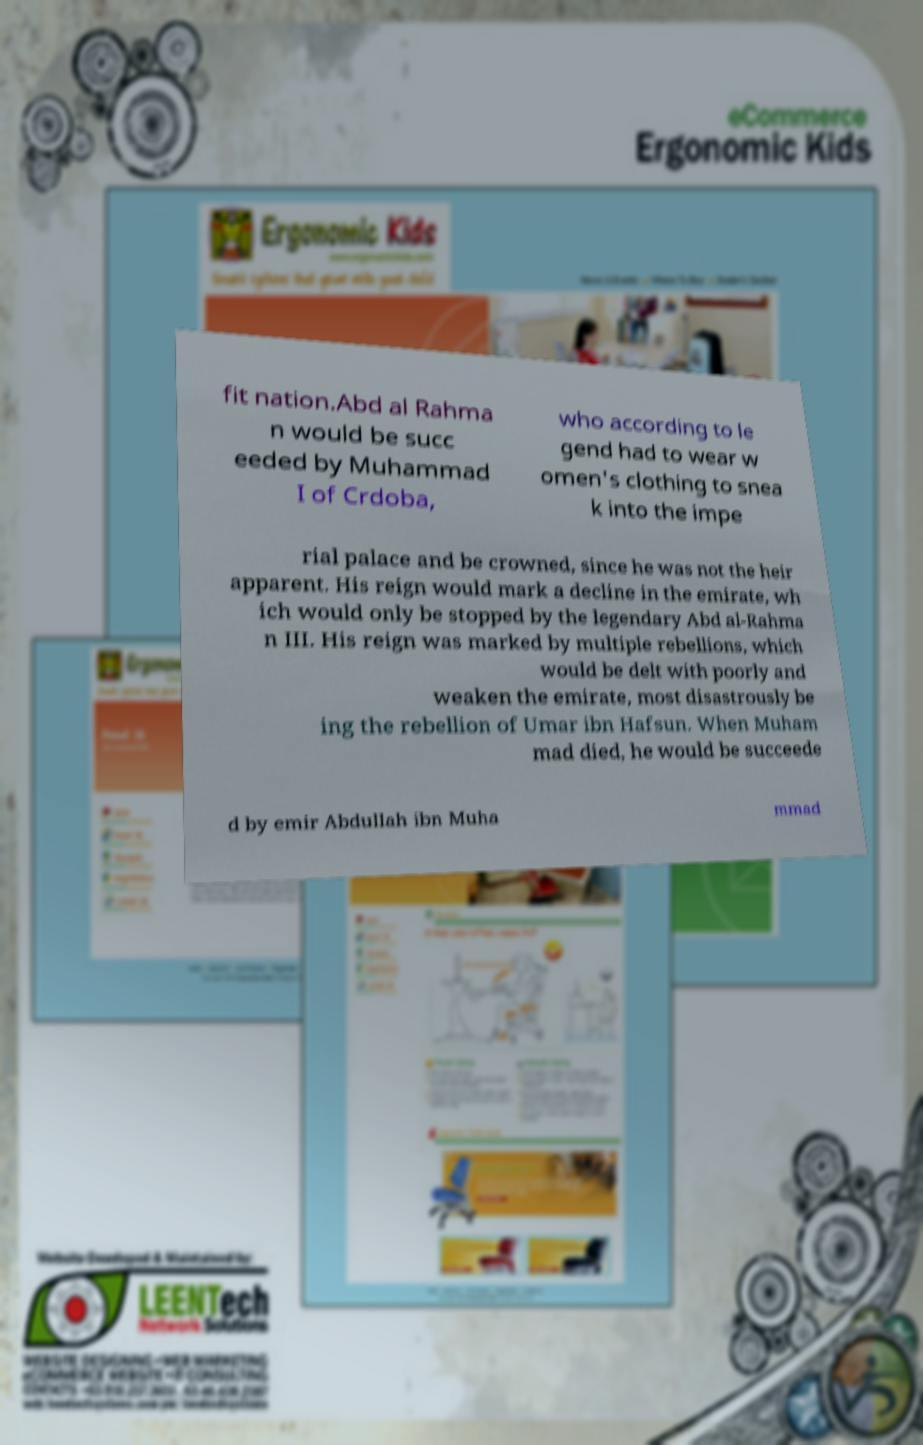Can you accurately transcribe the text from the provided image for me? fit nation.Abd al Rahma n would be succ eeded by Muhammad I of Crdoba, who according to le gend had to wear w omen's clothing to snea k into the impe rial palace and be crowned, since he was not the heir apparent. His reign would mark a decline in the emirate, wh ich would only be stopped by the legendary Abd al-Rahma n III. His reign was marked by multiple rebellions, which would be delt with poorly and weaken the emirate, most disastrously be ing the rebellion of Umar ibn Hafsun. When Muham mad died, he would be succeede d by emir Abdullah ibn Muha mmad 